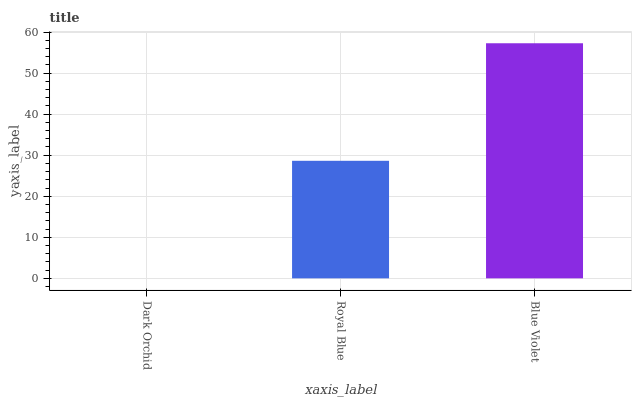Is Royal Blue the minimum?
Answer yes or no. No. Is Royal Blue the maximum?
Answer yes or no. No. Is Royal Blue greater than Dark Orchid?
Answer yes or no. Yes. Is Dark Orchid less than Royal Blue?
Answer yes or no. Yes. Is Dark Orchid greater than Royal Blue?
Answer yes or no. No. Is Royal Blue less than Dark Orchid?
Answer yes or no. No. Is Royal Blue the high median?
Answer yes or no. Yes. Is Royal Blue the low median?
Answer yes or no. Yes. Is Blue Violet the high median?
Answer yes or no. No. Is Blue Violet the low median?
Answer yes or no. No. 